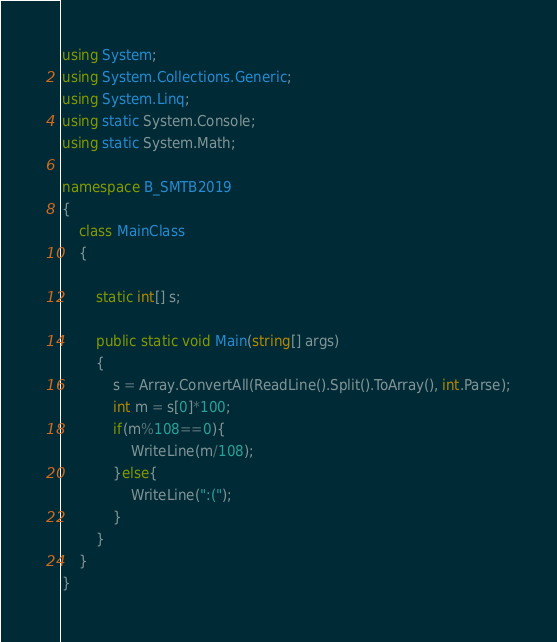<code> <loc_0><loc_0><loc_500><loc_500><_C#_>using System;
using System.Collections.Generic;
using System.Linq;
using static System.Console;
using static System.Math;

namespace B_SMTB2019
{
    class MainClass
    {

        static int[] s;

        public static void Main(string[] args)
        {
            s = Array.ConvertAll(ReadLine().Split().ToArray(), int.Parse);
            int m = s[0]*100;
            if(m%108==0){
                WriteLine(m/108);
            }else{
                WriteLine(":(");
            }
        }
    }
}
</code> 